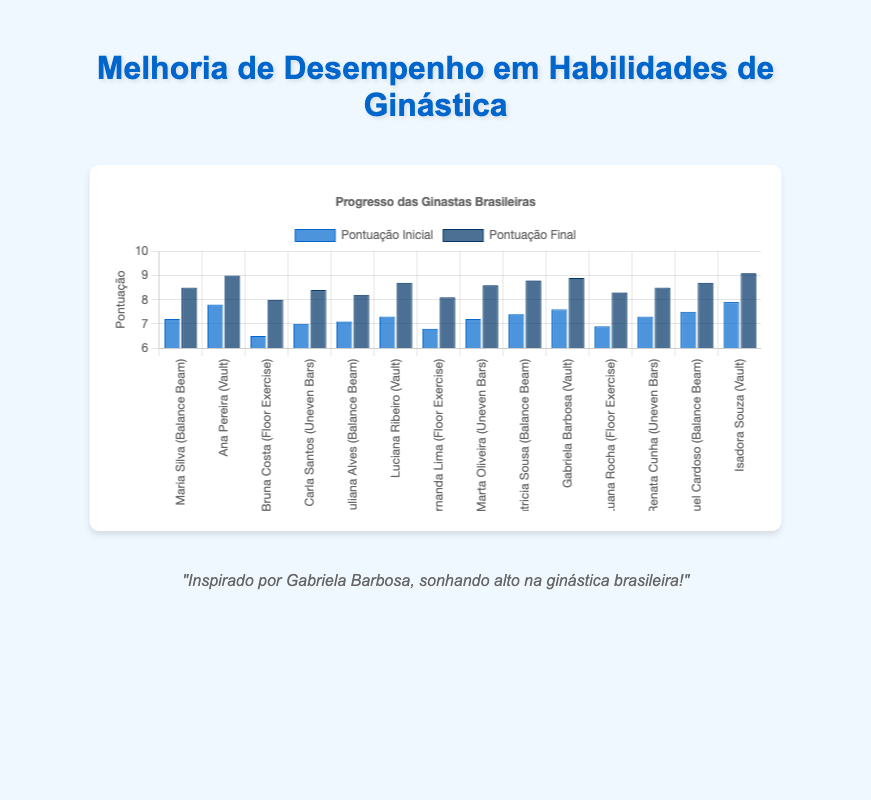Which gymnast showed the greatest improvement on the Balance Beam? To determine the greatest improvement, subtract the initial score from the final score for each gymnast on the Balance Beam, then identify the largest value among these differences. For Maria Silva, it's 8.5 - 7.2 = 1.3, Juliana Alves = 8.2 - 7.1 = 1.1, Patricia Sousa = 8.8 - 7.4 = 1.4, and Raquel Cardoso = 8.7 - 7.5 = 1.2. So, Patricia Sousa showed the greatest improvement with a difference of 1.4.
Answer: Patricia Sousa Which skill had the highest initial score? Compare the initial scores of each skill: Balance Beam (7.2, 7.1, 7.4, 7.5), Vault (7.8, 7.3, 7.6, 7.9), Floor Exercise (6.5, 6.8, 6.9), Uneven Bars (7.0, 7.2, 7.3). The highest initial score is in Vault, with 7.9 by Isadora Souza.
Answer: Vault Who had the highest final score in Floor Exercise? Review the final scores for the Floor Exercise: 8.0 (Bruna Costa), 8.1 (Fernanda Lima), and 8.3 (Luana Rocha). The highest final score is 8.3 by Luana Rocha.
Answer: Luana Rocha Which skill had the overall highest improvement? Calculate the overall improvement by summing the differences between the final and initial scores for each skill: Balance Beam = (1.3 + 1.1 + 1.4 + 1.2) = 5.0, Vault = (1.2 + 1.4 + 1.3 + 1.2) = 5.1, Floor Exercise = (1.5 + 1.3 + 1.4) = 4.2, Uneven Bars = (1.4 + 1.4 + 1.2) = 4.4. Vault has the highest overall improvement.
Answer: Vault Which gymnast had the smallest improvement on any skill? Calculate the improvement for each gymnast in each skill, then determine the smallest value: Maria Silva (1.3), Ana Pereira (1.2), Bruna Costa (1.5), Carla Santos (1.4), Juliana Alves (1.1), Luciana Ribeiro (1.4), Fernanda Lima (1.3), Marta Oliveira (1.4), Patricia Sousa (1.4), Gabriela Barbosa (1.3), Luana Rocha (1.4), Renata Cunha (1.2), Raquel Cardoso (1.2), Isadora Souza (1.2). Juliana Alves showed the smallest improvement of 1.1.
Answer: Juliana Alves What is the average final score for the Uneven Bars? Add up the final scores for Uneven Bars and divide by the number of gymnasts: (8.4 + 8.6 + 8.5) / 3 = 25.5 / 3 = 8.5.
Answer: 8.5 Which gymnast had the largest difference between their initial and final scores? Calculate the difference for each gymnast and identify the largest: Maria Silva (1.3), Ana Pereira (1.2), Bruna Costa (1.5), Carla Santos (1.4), Juliana Alves (1.1), Luciana Ribeiro (1.4), Fernanda Lima (1.3), Marta Oliveira (1.4), Patricia Sousa (1.4), Gabriela Barbosa (1.3), Luana Rocha (1.4), Renata Cunha (1.2), Raquel Cardoso (1.2), Isadora Souza (1.2). Bruna Costa showed the largest difference of 1.5.
Answer: Bruna Costa 